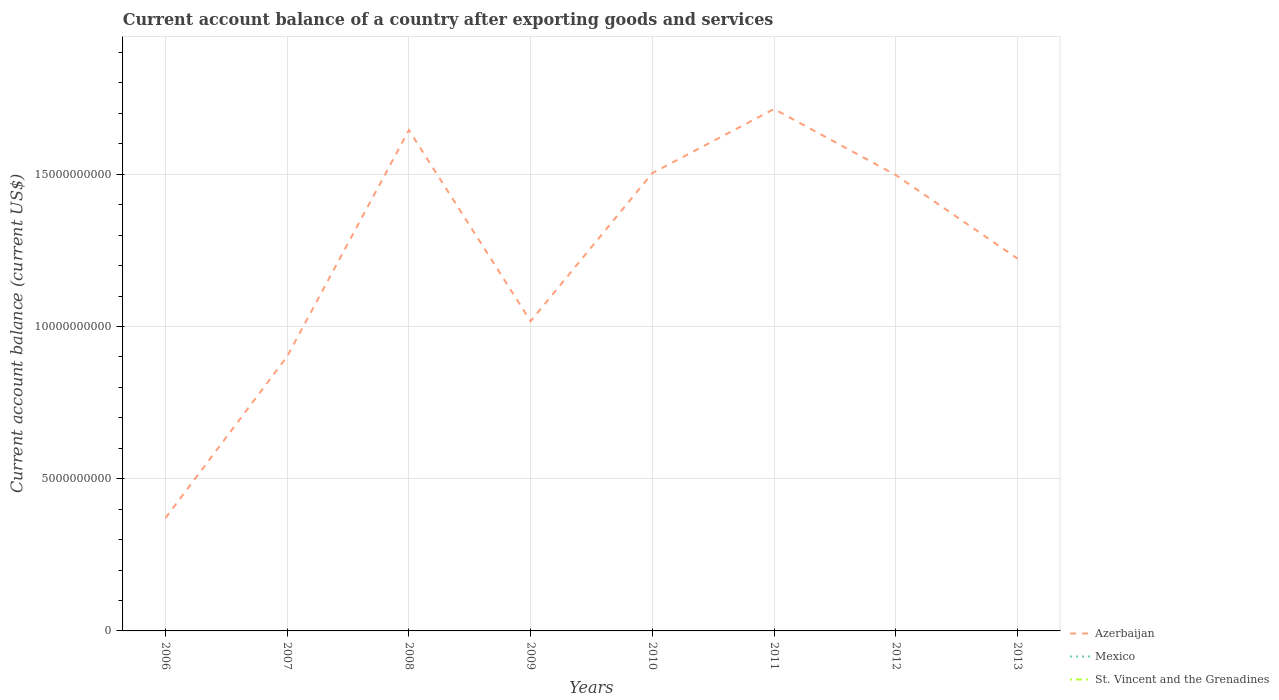Is the number of lines equal to the number of legend labels?
Provide a short and direct response. No. What is the total account balance in Azerbaijan in the graph?
Make the answer very short. 6.44e+07. What is the difference between the highest and the second highest account balance in Azerbaijan?
Offer a very short reply. 1.34e+1. What is the difference between the highest and the lowest account balance in St. Vincent and the Grenadines?
Your answer should be very brief. 0. Is the account balance in Azerbaijan strictly greater than the account balance in St. Vincent and the Grenadines over the years?
Your answer should be very brief. No. How many lines are there?
Your response must be concise. 1. How many years are there in the graph?
Your response must be concise. 8. What is the difference between two consecutive major ticks on the Y-axis?
Ensure brevity in your answer.  5.00e+09. Are the values on the major ticks of Y-axis written in scientific E-notation?
Provide a short and direct response. No. Does the graph contain any zero values?
Give a very brief answer. Yes. How many legend labels are there?
Your answer should be very brief. 3. How are the legend labels stacked?
Keep it short and to the point. Vertical. What is the title of the graph?
Keep it short and to the point. Current account balance of a country after exporting goods and services. Does "Czech Republic" appear as one of the legend labels in the graph?
Offer a terse response. No. What is the label or title of the Y-axis?
Give a very brief answer. Current account balance (current US$). What is the Current account balance (current US$) in Azerbaijan in 2006?
Your answer should be very brief. 3.71e+09. What is the Current account balance (current US$) of Mexico in 2006?
Provide a short and direct response. 0. What is the Current account balance (current US$) of Azerbaijan in 2007?
Ensure brevity in your answer.  9.02e+09. What is the Current account balance (current US$) in St. Vincent and the Grenadines in 2007?
Provide a succinct answer. 0. What is the Current account balance (current US$) of Azerbaijan in 2008?
Offer a very short reply. 1.65e+1. What is the Current account balance (current US$) in Mexico in 2008?
Your answer should be compact. 0. What is the Current account balance (current US$) of Azerbaijan in 2009?
Provide a short and direct response. 1.02e+1. What is the Current account balance (current US$) in St. Vincent and the Grenadines in 2009?
Ensure brevity in your answer.  0. What is the Current account balance (current US$) of Azerbaijan in 2010?
Keep it short and to the point. 1.50e+1. What is the Current account balance (current US$) in Mexico in 2010?
Offer a terse response. 0. What is the Current account balance (current US$) of St. Vincent and the Grenadines in 2010?
Give a very brief answer. 0. What is the Current account balance (current US$) in Azerbaijan in 2011?
Ensure brevity in your answer.  1.71e+1. What is the Current account balance (current US$) of Mexico in 2011?
Your answer should be compact. 0. What is the Current account balance (current US$) in Azerbaijan in 2012?
Give a very brief answer. 1.50e+1. What is the Current account balance (current US$) of Azerbaijan in 2013?
Your answer should be very brief. 1.22e+1. What is the Current account balance (current US$) in Mexico in 2013?
Your response must be concise. 0. What is the Current account balance (current US$) in St. Vincent and the Grenadines in 2013?
Give a very brief answer. 0. Across all years, what is the maximum Current account balance (current US$) in Azerbaijan?
Ensure brevity in your answer.  1.71e+1. Across all years, what is the minimum Current account balance (current US$) in Azerbaijan?
Offer a very short reply. 3.71e+09. What is the total Current account balance (current US$) of Azerbaijan in the graph?
Provide a succinct answer. 9.87e+1. What is the difference between the Current account balance (current US$) of Azerbaijan in 2006 and that in 2007?
Your answer should be very brief. -5.31e+09. What is the difference between the Current account balance (current US$) of Azerbaijan in 2006 and that in 2008?
Keep it short and to the point. -1.27e+1. What is the difference between the Current account balance (current US$) in Azerbaijan in 2006 and that in 2009?
Offer a very short reply. -6.47e+09. What is the difference between the Current account balance (current US$) of Azerbaijan in 2006 and that in 2010?
Keep it short and to the point. -1.13e+1. What is the difference between the Current account balance (current US$) in Azerbaijan in 2006 and that in 2011?
Provide a short and direct response. -1.34e+1. What is the difference between the Current account balance (current US$) in Azerbaijan in 2006 and that in 2012?
Make the answer very short. -1.13e+1. What is the difference between the Current account balance (current US$) of Azerbaijan in 2006 and that in 2013?
Keep it short and to the point. -8.52e+09. What is the difference between the Current account balance (current US$) in Azerbaijan in 2007 and that in 2008?
Your answer should be compact. -7.43e+09. What is the difference between the Current account balance (current US$) of Azerbaijan in 2007 and that in 2009?
Your answer should be compact. -1.16e+09. What is the difference between the Current account balance (current US$) of Azerbaijan in 2007 and that in 2010?
Make the answer very short. -6.02e+09. What is the difference between the Current account balance (current US$) in Azerbaijan in 2007 and that in 2011?
Your response must be concise. -8.13e+09. What is the difference between the Current account balance (current US$) in Azerbaijan in 2007 and that in 2012?
Offer a very short reply. -5.96e+09. What is the difference between the Current account balance (current US$) in Azerbaijan in 2007 and that in 2013?
Make the answer very short. -3.21e+09. What is the difference between the Current account balance (current US$) of Azerbaijan in 2008 and that in 2009?
Provide a short and direct response. 6.28e+09. What is the difference between the Current account balance (current US$) of Azerbaijan in 2008 and that in 2010?
Offer a terse response. 1.41e+09. What is the difference between the Current account balance (current US$) of Azerbaijan in 2008 and that in 2011?
Provide a short and direct response. -6.92e+08. What is the difference between the Current account balance (current US$) of Azerbaijan in 2008 and that in 2012?
Offer a very short reply. 1.48e+09. What is the difference between the Current account balance (current US$) of Azerbaijan in 2008 and that in 2013?
Provide a succinct answer. 4.22e+09. What is the difference between the Current account balance (current US$) in Azerbaijan in 2009 and that in 2010?
Keep it short and to the point. -4.87e+09. What is the difference between the Current account balance (current US$) in Azerbaijan in 2009 and that in 2011?
Keep it short and to the point. -6.97e+09. What is the difference between the Current account balance (current US$) in Azerbaijan in 2009 and that in 2012?
Ensure brevity in your answer.  -4.80e+09. What is the difference between the Current account balance (current US$) of Azerbaijan in 2009 and that in 2013?
Ensure brevity in your answer.  -2.06e+09. What is the difference between the Current account balance (current US$) in Azerbaijan in 2010 and that in 2011?
Your answer should be very brief. -2.10e+09. What is the difference between the Current account balance (current US$) of Azerbaijan in 2010 and that in 2012?
Keep it short and to the point. 6.44e+07. What is the difference between the Current account balance (current US$) of Azerbaijan in 2010 and that in 2013?
Keep it short and to the point. 2.81e+09. What is the difference between the Current account balance (current US$) in Azerbaijan in 2011 and that in 2012?
Keep it short and to the point. 2.17e+09. What is the difference between the Current account balance (current US$) of Azerbaijan in 2011 and that in 2013?
Keep it short and to the point. 4.91e+09. What is the difference between the Current account balance (current US$) in Azerbaijan in 2012 and that in 2013?
Your answer should be very brief. 2.74e+09. What is the average Current account balance (current US$) in Azerbaijan per year?
Offer a very short reply. 1.23e+1. What is the average Current account balance (current US$) of St. Vincent and the Grenadines per year?
Make the answer very short. 0. What is the ratio of the Current account balance (current US$) in Azerbaijan in 2006 to that in 2007?
Ensure brevity in your answer.  0.41. What is the ratio of the Current account balance (current US$) of Azerbaijan in 2006 to that in 2008?
Your response must be concise. 0.23. What is the ratio of the Current account balance (current US$) of Azerbaijan in 2006 to that in 2009?
Your answer should be very brief. 0.36. What is the ratio of the Current account balance (current US$) of Azerbaijan in 2006 to that in 2010?
Provide a short and direct response. 0.25. What is the ratio of the Current account balance (current US$) in Azerbaijan in 2006 to that in 2011?
Your response must be concise. 0.22. What is the ratio of the Current account balance (current US$) in Azerbaijan in 2006 to that in 2012?
Offer a very short reply. 0.25. What is the ratio of the Current account balance (current US$) of Azerbaijan in 2006 to that in 2013?
Provide a succinct answer. 0.3. What is the ratio of the Current account balance (current US$) in Azerbaijan in 2007 to that in 2008?
Your response must be concise. 0.55. What is the ratio of the Current account balance (current US$) of Azerbaijan in 2007 to that in 2009?
Give a very brief answer. 0.89. What is the ratio of the Current account balance (current US$) of Azerbaijan in 2007 to that in 2010?
Keep it short and to the point. 0.6. What is the ratio of the Current account balance (current US$) in Azerbaijan in 2007 to that in 2011?
Offer a very short reply. 0.53. What is the ratio of the Current account balance (current US$) of Azerbaijan in 2007 to that in 2012?
Provide a short and direct response. 0.6. What is the ratio of the Current account balance (current US$) of Azerbaijan in 2007 to that in 2013?
Your answer should be compact. 0.74. What is the ratio of the Current account balance (current US$) of Azerbaijan in 2008 to that in 2009?
Your response must be concise. 1.62. What is the ratio of the Current account balance (current US$) in Azerbaijan in 2008 to that in 2010?
Your answer should be very brief. 1.09. What is the ratio of the Current account balance (current US$) of Azerbaijan in 2008 to that in 2011?
Provide a short and direct response. 0.96. What is the ratio of the Current account balance (current US$) of Azerbaijan in 2008 to that in 2012?
Provide a short and direct response. 1.1. What is the ratio of the Current account balance (current US$) of Azerbaijan in 2008 to that in 2013?
Make the answer very short. 1.35. What is the ratio of the Current account balance (current US$) in Azerbaijan in 2009 to that in 2010?
Your response must be concise. 0.68. What is the ratio of the Current account balance (current US$) in Azerbaijan in 2009 to that in 2011?
Ensure brevity in your answer.  0.59. What is the ratio of the Current account balance (current US$) of Azerbaijan in 2009 to that in 2012?
Offer a very short reply. 0.68. What is the ratio of the Current account balance (current US$) of Azerbaijan in 2009 to that in 2013?
Your response must be concise. 0.83. What is the ratio of the Current account balance (current US$) of Azerbaijan in 2010 to that in 2011?
Offer a very short reply. 0.88. What is the ratio of the Current account balance (current US$) of Azerbaijan in 2010 to that in 2013?
Offer a very short reply. 1.23. What is the ratio of the Current account balance (current US$) of Azerbaijan in 2011 to that in 2012?
Offer a terse response. 1.14. What is the ratio of the Current account balance (current US$) in Azerbaijan in 2011 to that in 2013?
Provide a succinct answer. 1.4. What is the ratio of the Current account balance (current US$) of Azerbaijan in 2012 to that in 2013?
Make the answer very short. 1.22. What is the difference between the highest and the second highest Current account balance (current US$) in Azerbaijan?
Offer a very short reply. 6.92e+08. What is the difference between the highest and the lowest Current account balance (current US$) in Azerbaijan?
Give a very brief answer. 1.34e+1. 